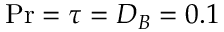Convert formula to latex. <formula><loc_0><loc_0><loc_500><loc_500>{ P r } = \tau = D _ { B } = 0 . 1</formula> 